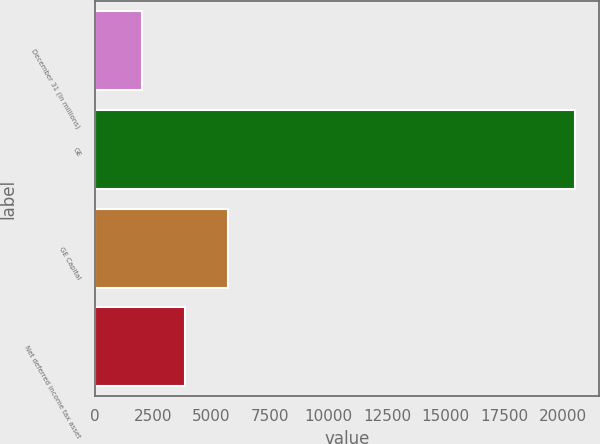Convert chart. <chart><loc_0><loc_0><loc_500><loc_500><bar_chart><fcel>December 31 (In millions)<fcel>GE<fcel>GE Capital<fcel>Net deferred income tax asset<nl><fcel>2015<fcel>20539<fcel>5719.8<fcel>3867.4<nl></chart> 